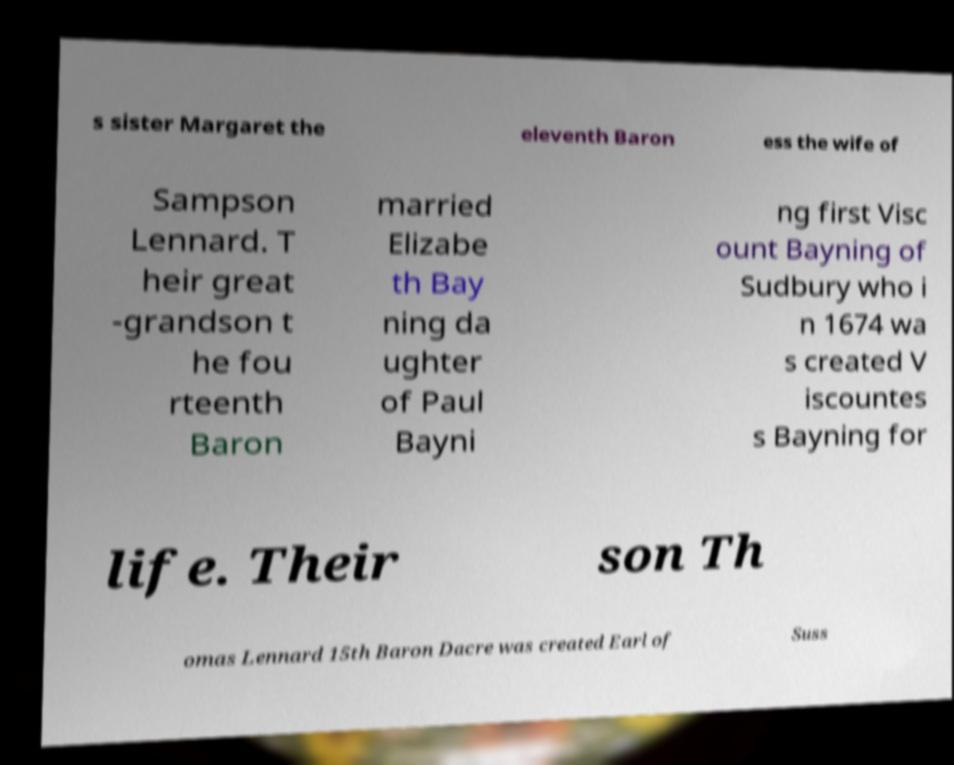Can you read and provide the text displayed in the image?This photo seems to have some interesting text. Can you extract and type it out for me? s sister Margaret the eleventh Baron ess the wife of Sampson Lennard. T heir great -grandson t he fou rteenth Baron married Elizabe th Bay ning da ughter of Paul Bayni ng first Visc ount Bayning of Sudbury who i n 1674 wa s created V iscountes s Bayning for life. Their son Th omas Lennard 15th Baron Dacre was created Earl of Suss 